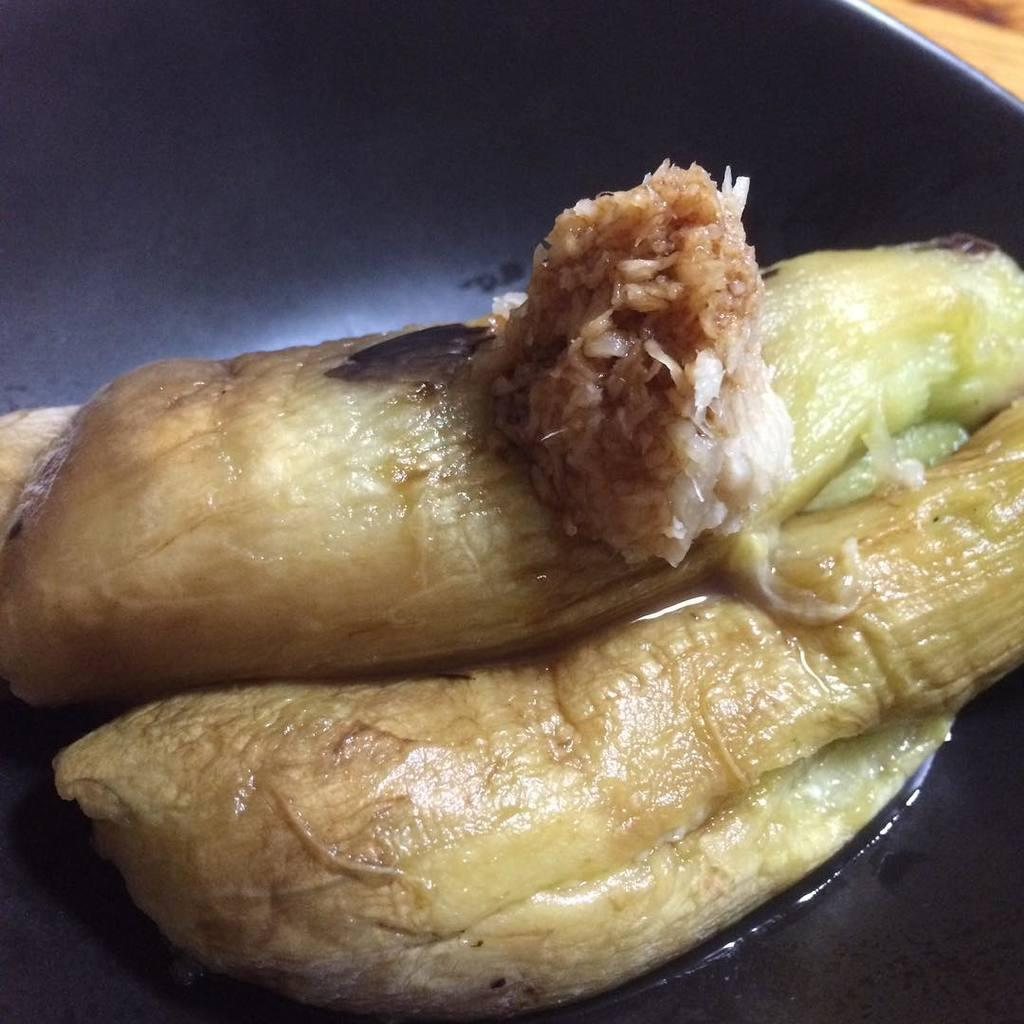What is on the plate in the image? There are food items on a plate. Where is the plate located in the image? The plate is placed on a surface. What effect does the afternoon have on the food items on the plate? The image does not provide information about the time of day or any effects on the food items. 